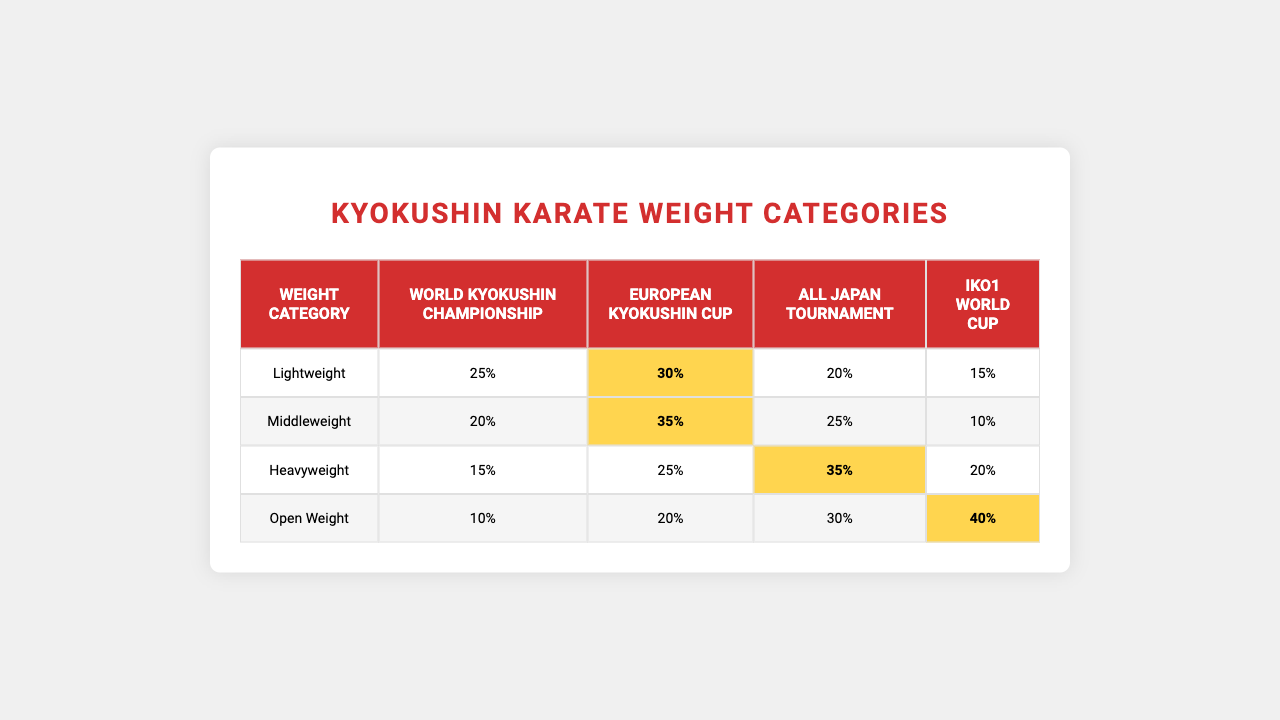What is the highest percentage representation for the Lightweight category in the competitions? Looking at the Lightweight row, the values are 25%, 20%, 15%, and 10% for the respective competitions. The highest value is 25% from the World Kyokushin Championship.
Answer: 25% Which weight category has the highest representation in the All Japan Tournament? The All Japan Tournament column shows values of 20%, 25%, 35%, and 30% for the different weight categories. The highest percentage is 35%, which belongs to the Heavyweight category.
Answer: Heavyweight What is the difference in percentage representation between the Middleweight and Open Weight categories in the IKO1 World Cup? For Middleweight, the percentage is 30%, and for Open Weight, it is 40%. The difference is 40% - 30% = 10%.
Answer: 10% Is the percentage representation for the Open Weight category uniform across the competitions? Looking at the Open Weight row, the values are 15%, 10%, 20%, and 40%. Since these values are not the same, the representation is not uniform.
Answer: No What is the total percentage representation for the Lightweight category across all competitions? Summing the percentages for the Lightweight category: 25% + 20% + 15% + 10% equals 70%.
Answer: 70% Which competition has the lowest overall percentages across all weight categories? By summing the values for each competition, we get: World Kyokushin Championship (25 + 20 + 15 + 10 = 70), European Kyokushin Cup (30 + 35 + 25 + 20 = 110), All Japan Tournament (20 + 25 + 35 + 30 = 110), and IKO1 World Cup (15 + 10 + 20 + 40 = 85). The World Kyokushin Championship has the lowest total of 70%.
Answer: World Kyokushin Championship What is the average percentage representation for the Heavyweight category? The percentages for the Heavyweight category are 20%, 25%, 35%, and 30%. To find the average, add these values (20 + 25 + 35 + 30 = 110) and divide by 4, resulting in an average of 27.5%.
Answer: 27.5% In which weight category does the IKO1 World Cup have the maximum representation? Checking the IKO1 World Cup row, the percentages are 15%, 10%, 20%, and 40%. The maximum representation is 40%, which corresponds to the Open Weight category.
Answer: Open Weight Which weight category has the least representation in the European Kyokushin Cup? In the European Kyokushin Cup, the representations are 30%, 35%, 25%, and 20%. The least representation is 20%, which corresponds to the Open Weight category.
Answer: Open Weight How many competitions have a representation of 30% or more for the Middleweight category? The Middleweight category has representations of 30%, 35%, 25%, and 20%. The values that are 30% or more are 30% and 35%. Therefore, there are 2 competitions with this representation.
Answer: 2 What is the representation of the Heavyweight category in the European Kyokushin Cup, and is it the highest among all categories for that competition? The representation for Heavyweight in the European Kyokushin Cup is 35%. Comparing it with others: Lightweight (30%), Middleweight (35%), Open Weight (20%), the highest representations are 35% for both Middleweight and Heavyweight, thus Heavyweight is not the highest alone.
Answer: No 